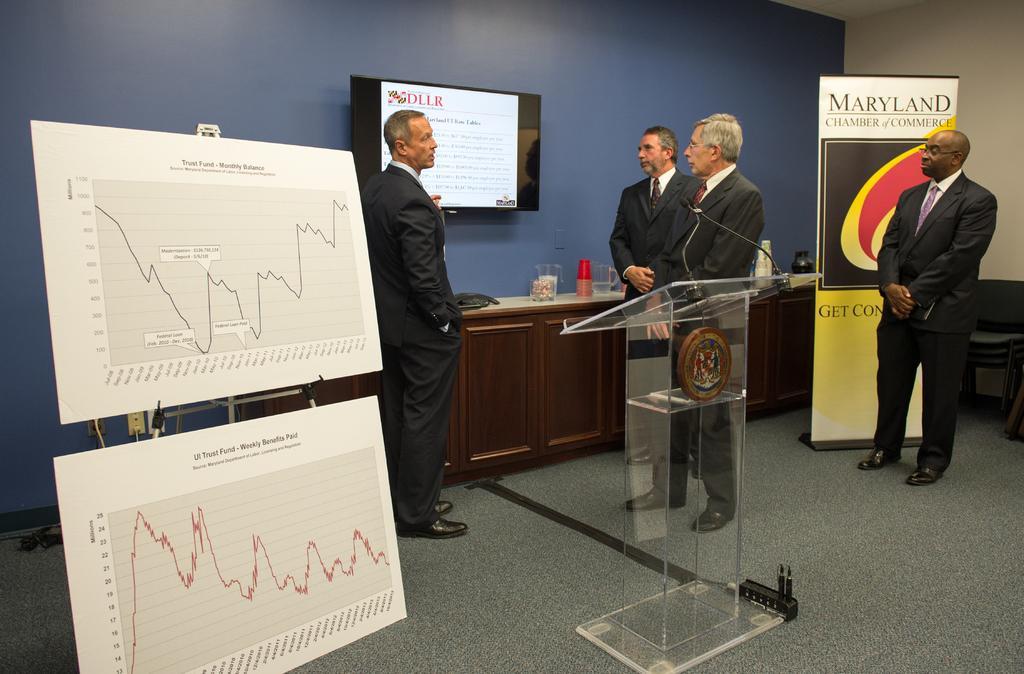Please provide a concise description of this image. This is an inside view of a room. On the left side there are two boards attached to a metal stand. On the right side there is a glass podium placed on the floor and there are four men standing. One man is speaking by looking at this three men. At the back of these people there is a table on which few objects are placed and also there is a monitor attached to the wall. In the background there is a banner on which I can see some text. 